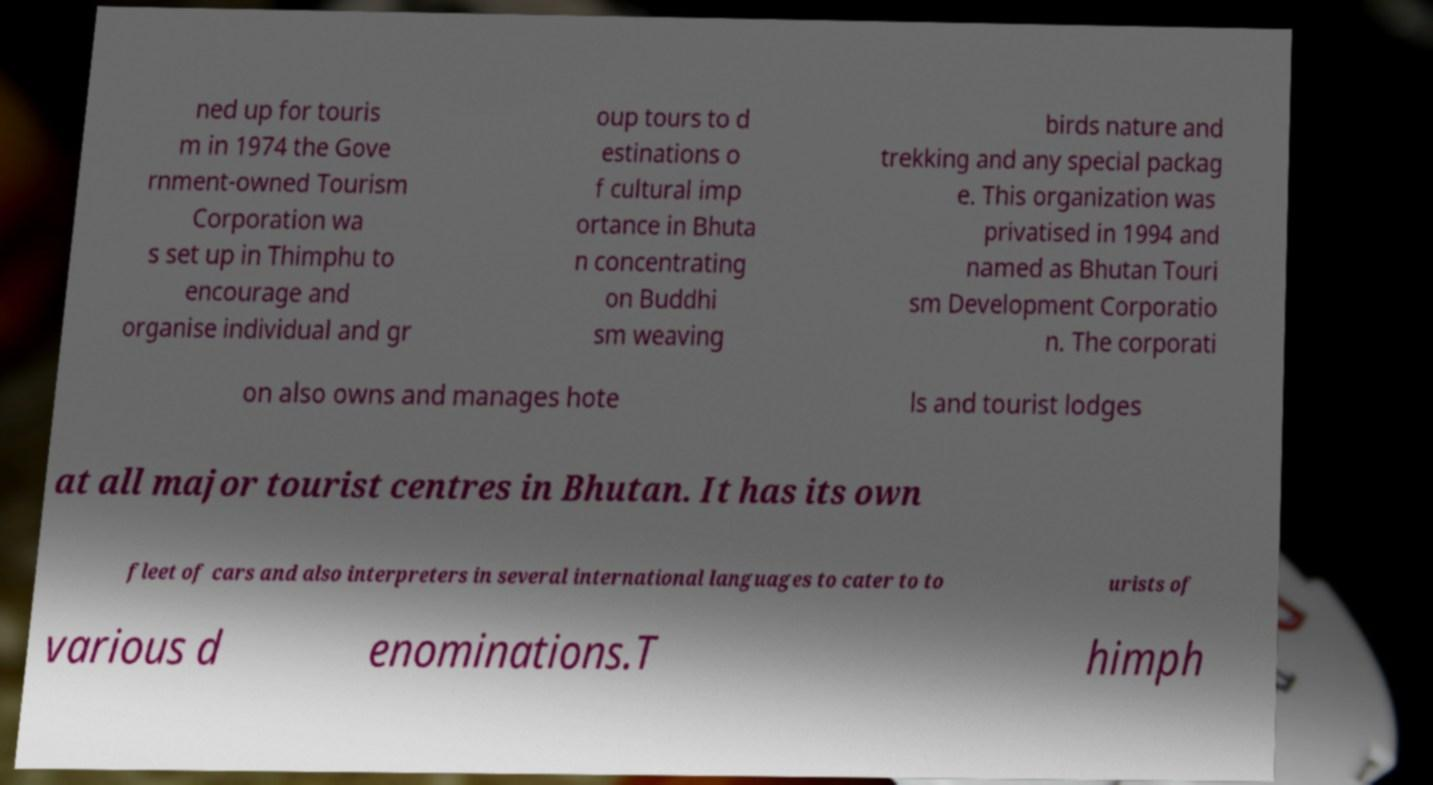There's text embedded in this image that I need extracted. Can you transcribe it verbatim? ned up for touris m in 1974 the Gove rnment-owned Tourism Corporation wa s set up in Thimphu to encourage and organise individual and gr oup tours to d estinations o f cultural imp ortance in Bhuta n concentrating on Buddhi sm weaving birds nature and trekking and any special packag e. This organization was privatised in 1994 and named as Bhutan Touri sm Development Corporatio n. The corporati on also owns and manages hote ls and tourist lodges at all major tourist centres in Bhutan. It has its own fleet of cars and also interpreters in several international languages to cater to to urists of various d enominations.T himph 